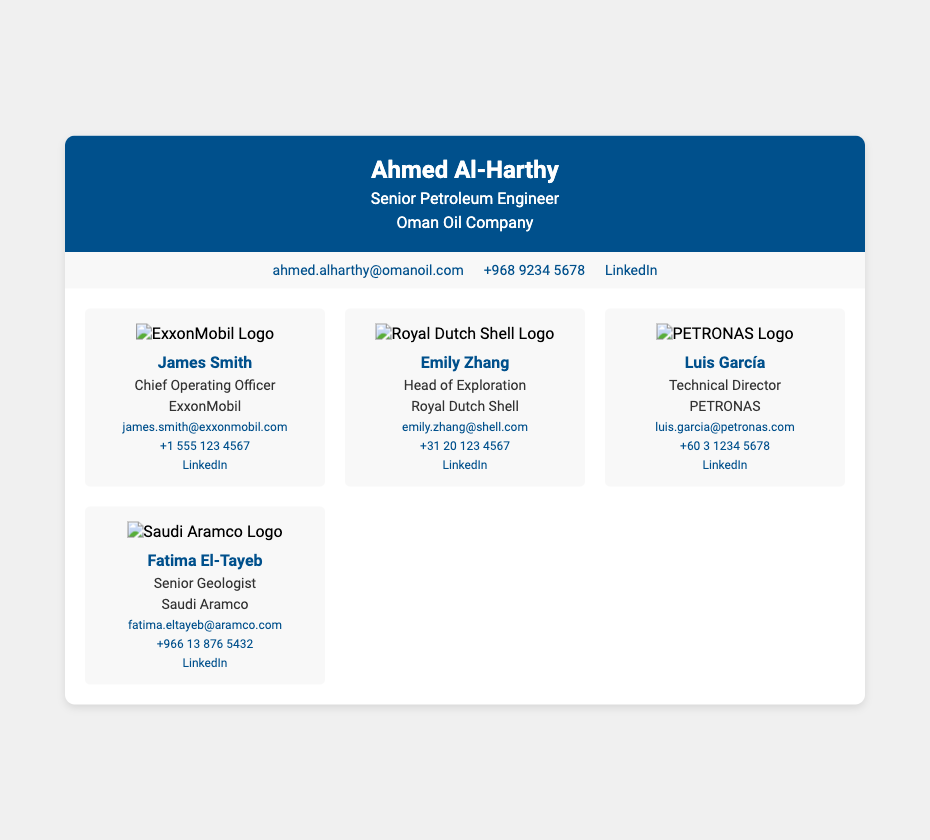What is the name of the senior petroleum engineer? The business card displays the name of the senior petroleum engineer as Ahmed Al-Harthy.
Answer: Ahmed Al-Harthy What company does Ahmed Al-Harthy work for? According to the header on the business card, Ahmed Al-Harthy works for Oman Oil Company.
Answer: Oman Oil Company Who is the Chief Operating Officer at ExxonMobil? The document identifies James Smith as the Chief Operating Officer at ExxonMobil.
Answer: James Smith What is Emily Zhang's role at Royal Dutch Shell? Emily Zhang's title at Royal Dutch Shell is Head of Exploration, as noted in her contact card.
Answer: Head of Exploration What is the contact email for Luis García? The business card provides the contact email for Luis García as luis.garcia@petronas.com.
Answer: luis.garcia@petronas.com How many key contacts are shown in the document? There are four key contacts showcased in the contact section of the business card.
Answer: Four What social media platform link is provided for James Smith? The document contains a LinkedIn link for James Smith, which is referenced in his contact details.
Answer: LinkedIn Which company does Fatima El-Tayeb work for? Fatima El-Tayeb is associated with Saudi Aramco, as indicated in her contact card.
Answer: Saudi Aramco What color is the header of the business card? The header of the business card is a shade of blue, specifically #00508c as used in the CSS styling.
Answer: Blue 